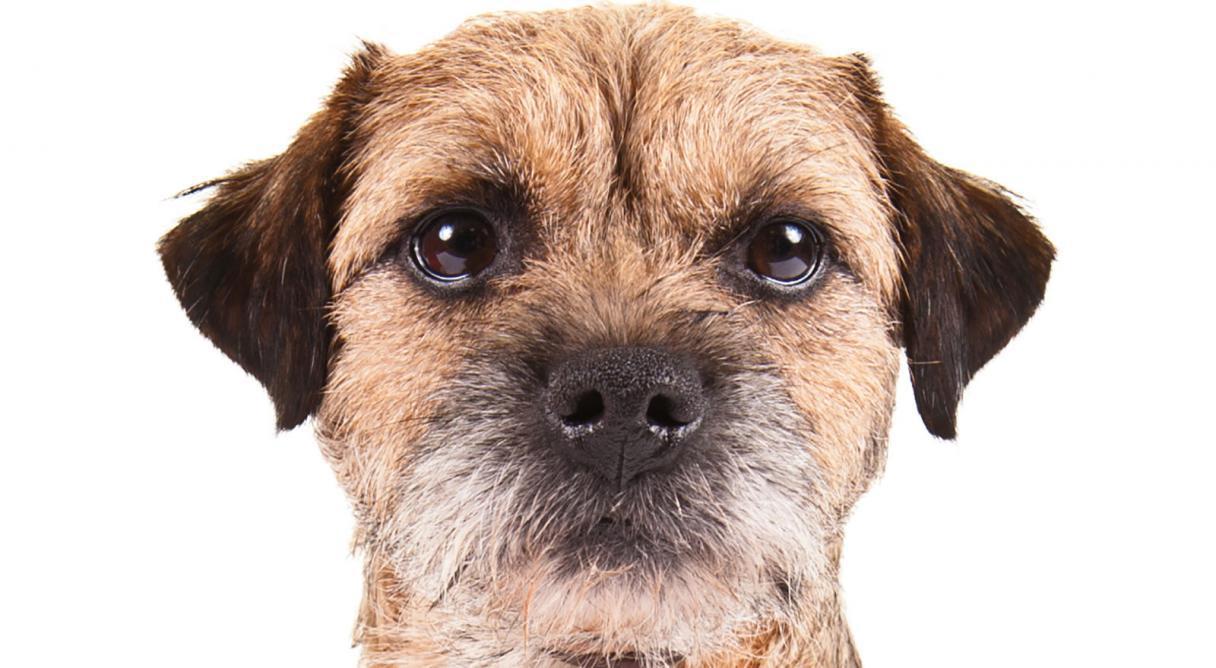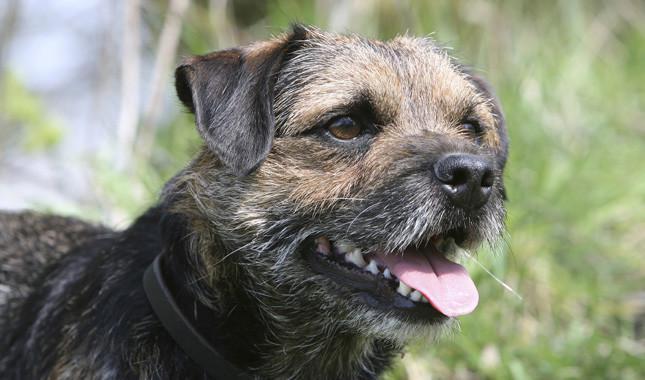The first image is the image on the left, the second image is the image on the right. Considering the images on both sides, is "An image includes a standing dog with its body turned leftward and its tail extended outward." valid? Answer yes or no. No. The first image is the image on the left, the second image is the image on the right. For the images shown, is this caption "The dog in the image on the left is on a green grassy surface." true? Answer yes or no. No. 